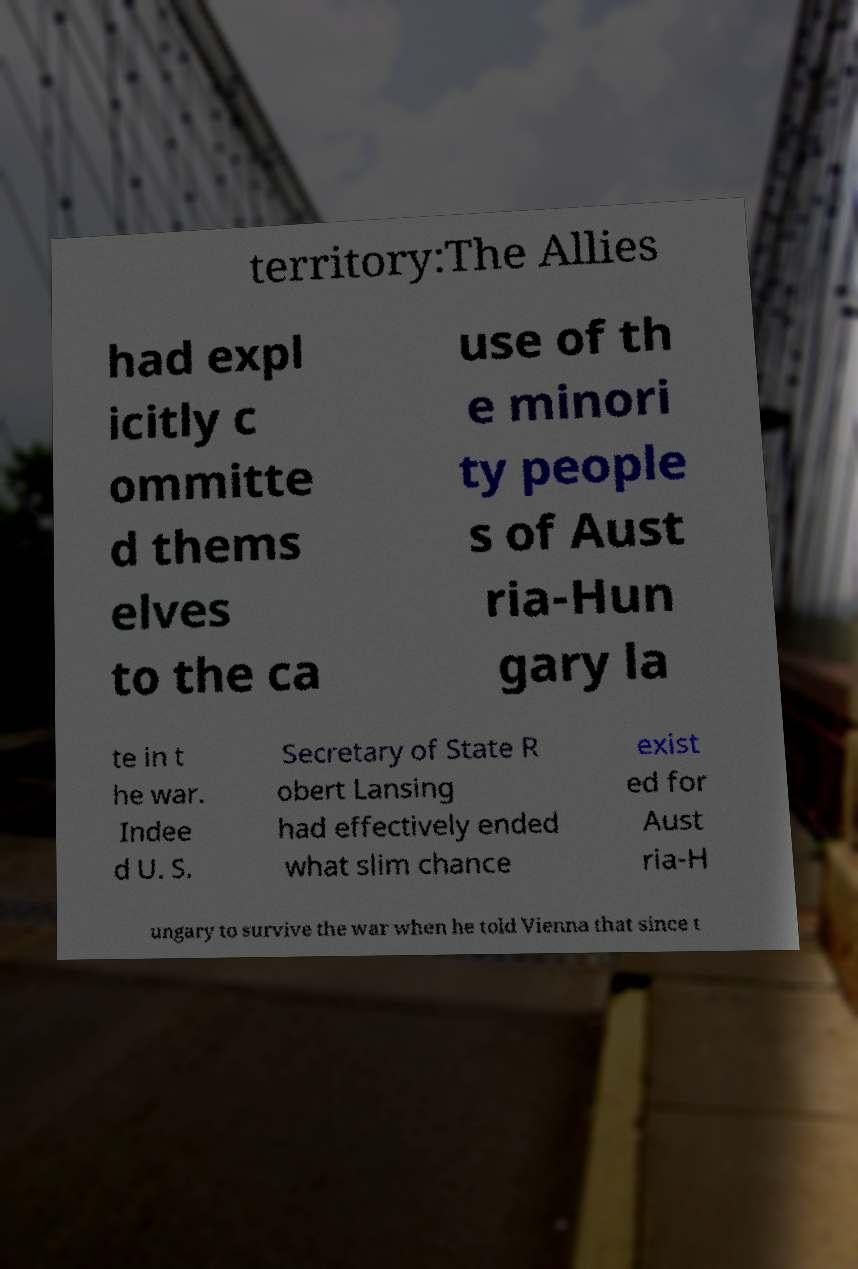For documentation purposes, I need the text within this image transcribed. Could you provide that? territory:The Allies had expl icitly c ommitte d thems elves to the ca use of th e minori ty people s of Aust ria-Hun gary la te in t he war. Indee d U. S. Secretary of State R obert Lansing had effectively ended what slim chance exist ed for Aust ria-H ungary to survive the war when he told Vienna that since t 